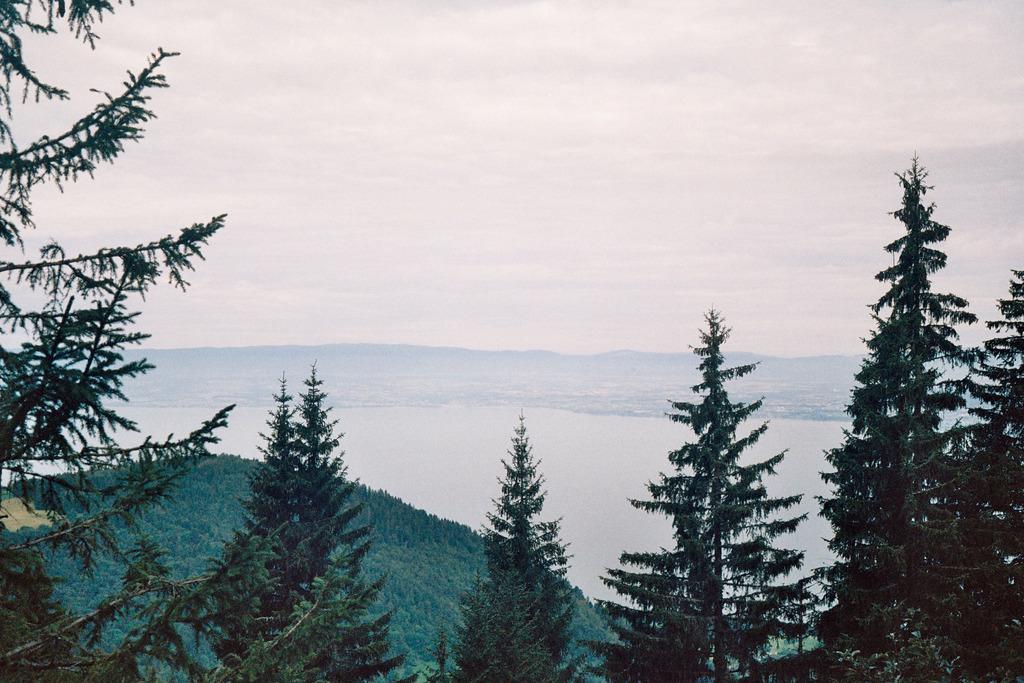How would you summarize this image in a sentence or two? In this image in front there are trees. And at the background there are mountains, Water and a sky. 